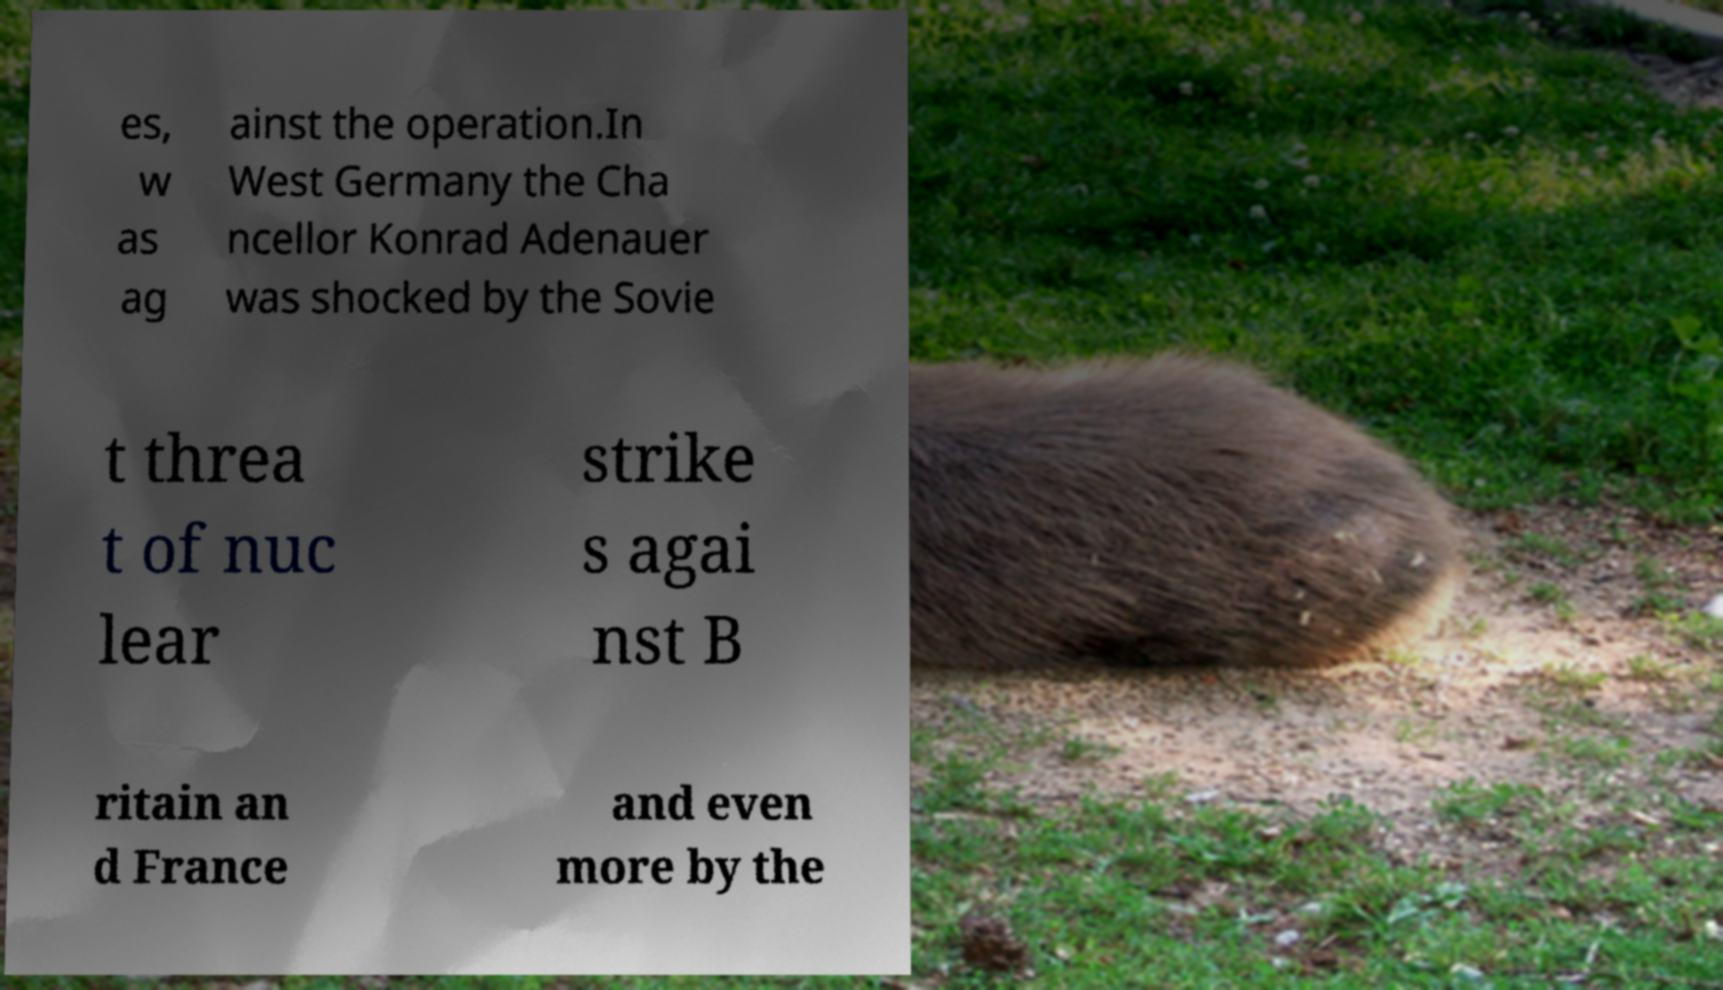Could you assist in decoding the text presented in this image and type it out clearly? es, w as ag ainst the operation.In West Germany the Cha ncellor Konrad Adenauer was shocked by the Sovie t threa t of nuc lear strike s agai nst B ritain an d France and even more by the 